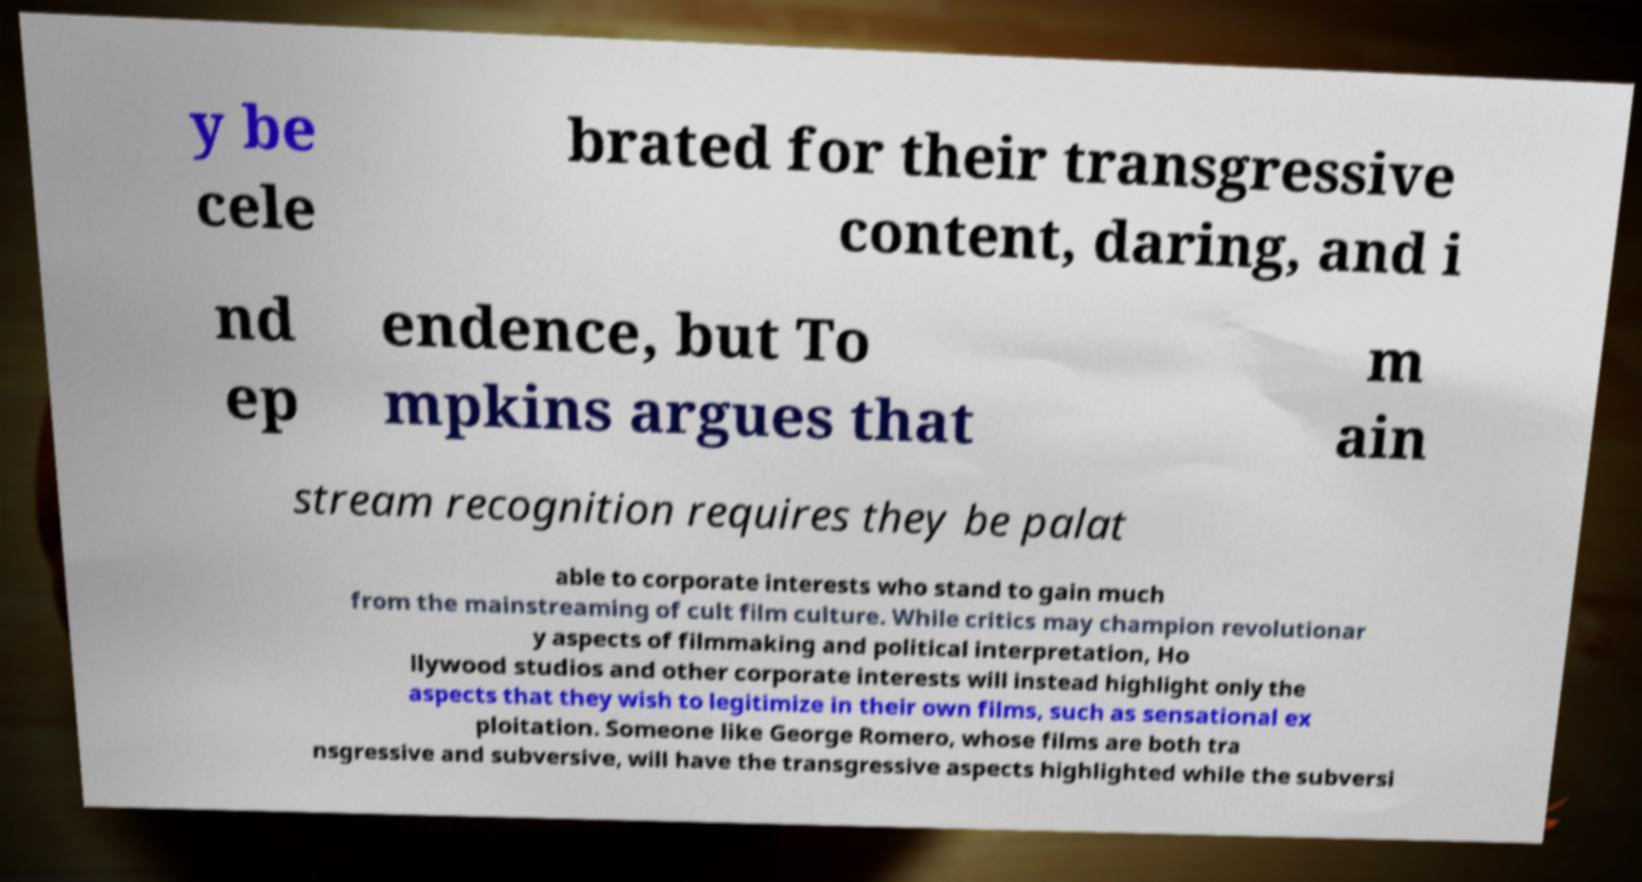Could you assist in decoding the text presented in this image and type it out clearly? y be cele brated for their transgressive content, daring, and i nd ep endence, but To mpkins argues that m ain stream recognition requires they be palat able to corporate interests who stand to gain much from the mainstreaming of cult film culture. While critics may champion revolutionar y aspects of filmmaking and political interpretation, Ho llywood studios and other corporate interests will instead highlight only the aspects that they wish to legitimize in their own films, such as sensational ex ploitation. Someone like George Romero, whose films are both tra nsgressive and subversive, will have the transgressive aspects highlighted while the subversi 